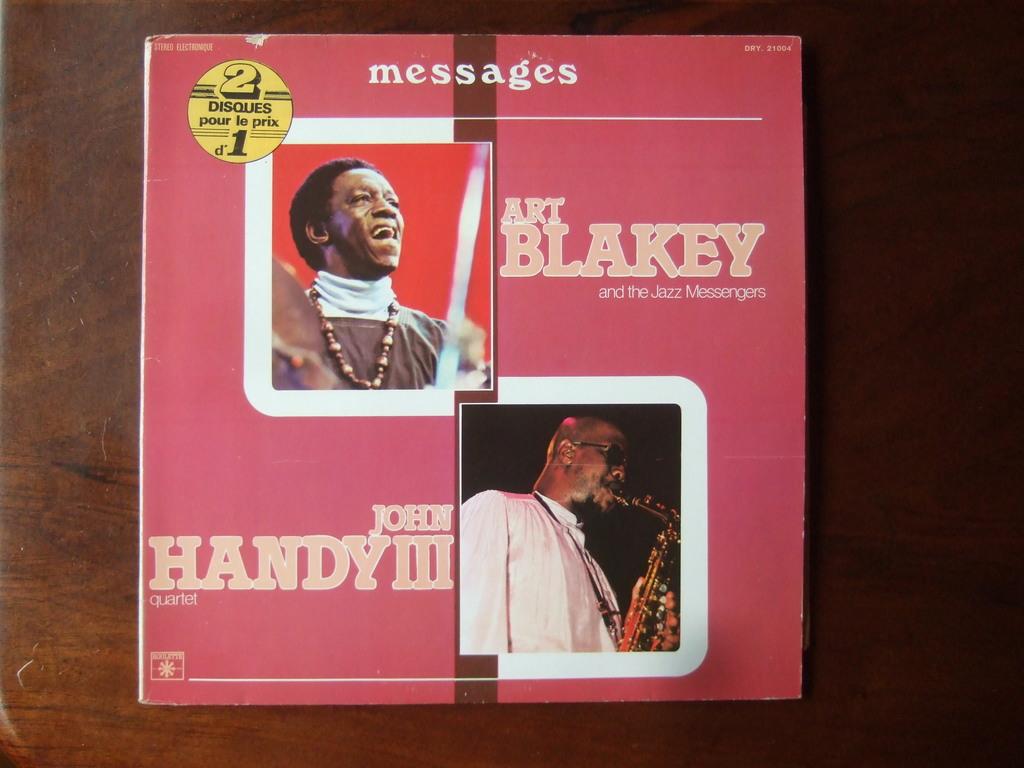Which artists are featured?
Provide a succinct answer. Art blakey john handy iii. What the album title?
Your answer should be very brief. Messages. 